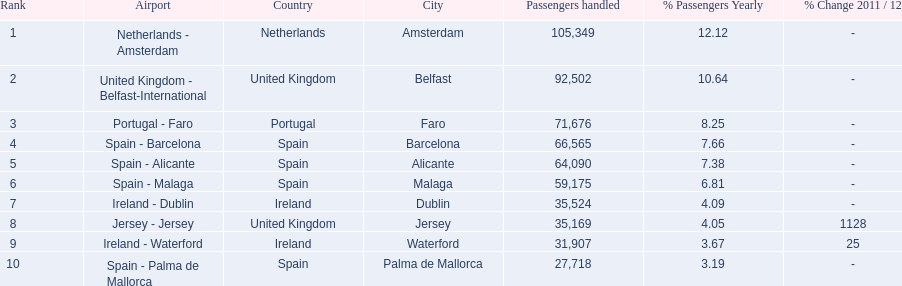What are all the airports in the top 10 busiest routes to and from london southend airport? Netherlands - Amsterdam, United Kingdom - Belfast-International, Portugal - Faro, Spain - Barcelona, Spain - Alicante, Spain - Malaga, Ireland - Dublin, Jersey - Jersey, Ireland - Waterford, Spain - Palma de Mallorca. Which airports are in portugal? Portugal - Faro. 